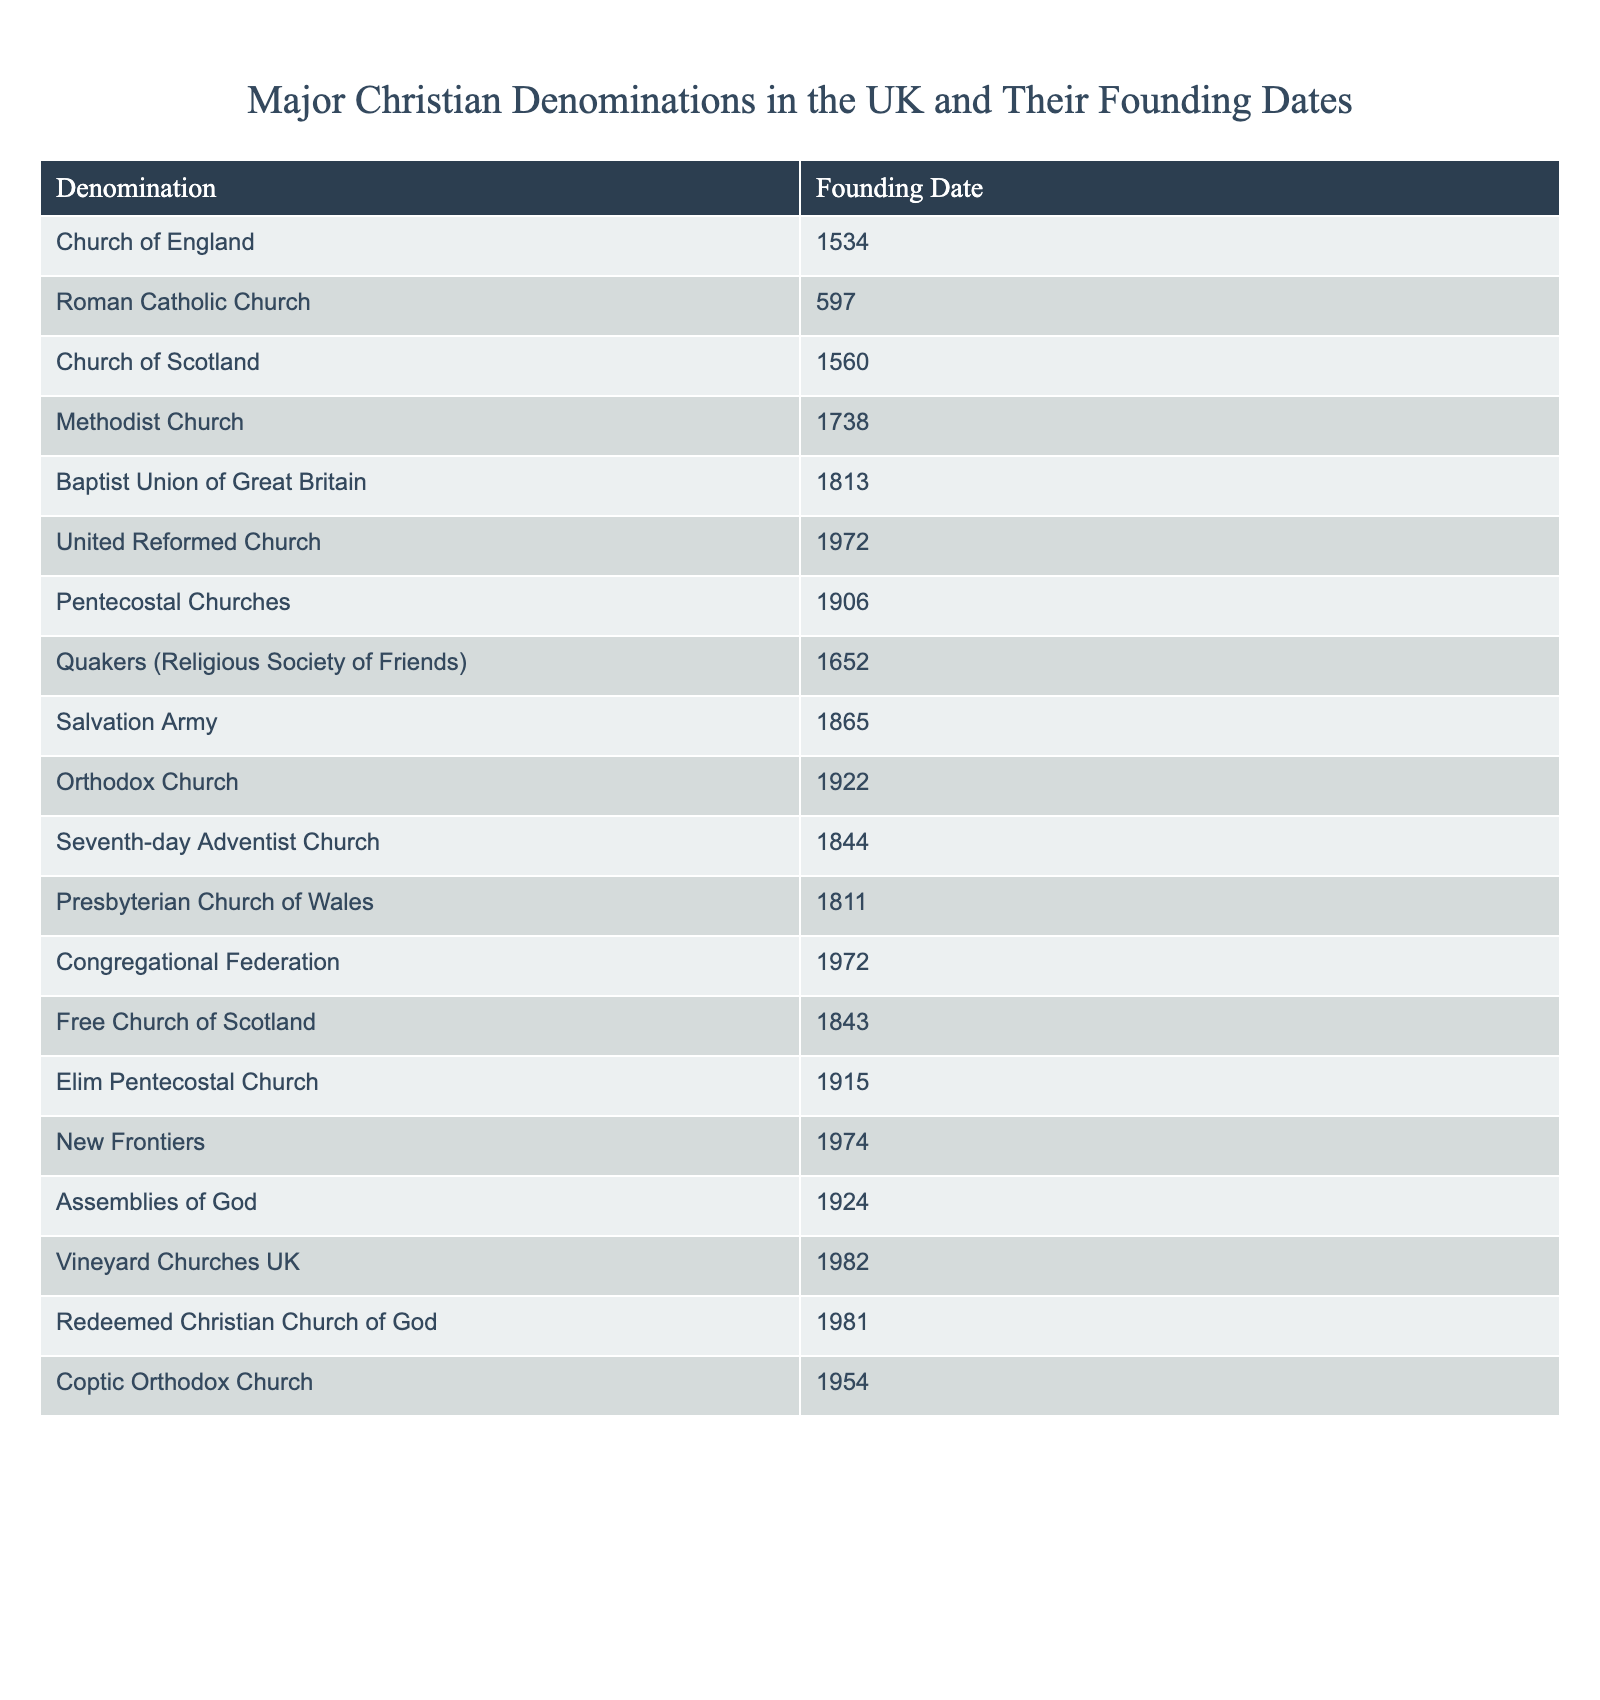What year was the Church of England founded? The founding date for the Church of England is listed in the table. I can directly refer to the row corresponding to the Church of England, which states that its founding date is 1534.
Answer: 1534 Which Christian denomination was founded first in the UK? To determine this, I can compare the founding dates of all denominations in the table. The Roman Catholic Church has the earliest founding date listed as 597.
Answer: Roman Catholic Church How many denominations were founded after 1800? First, I will filter the denominations founded after the year 1800, based on the founding dates provided. They are the Baptist Union of Great Britain (1813), Seventh-day Adventist Church (1844), Free Church of Scotland (1843), Salvation Army (1865), and Pentecostal Churches (1906). Counting these, we find there are 5 denominations.
Answer: 5 Is the United Reformed Church older than the Salvation Army? Looking at the founding years in the table, the United Reformed Church was founded in 1972, while the Salvation Army was founded in 1865. Since 1865 is earlier than 1972, the answer is no.
Answer: No Which denominations were founded in the 20th century? I need to identify which denominations emerged in the 1900s from the table. The denominations are the Pentecostal Churches (1906), Orthodox Church (1922), Assemblies of God (1924), Elim Pentecostal Church (1915), Vineyard Churches UK (1982), New Frontiers (1974), Coptic Orthodox Church (1954). Counting these gives us a total of 7 denominations.
Answer: 7 What is the difference in founding years between the Church of Scotland and the Methodist Church? The Church of Scotland was founded in 1560, while the Methodist Church was founded in 1738. To find the difference, I subtract 1560 from 1738, which equals 178 years.
Answer: 178 years Are there more denominations founded in the 16th century or the 19th century? I first identify the denominations from the table founded in the 16th century: Church of Scotland (1560) and Quakers (1652), totaling 2. For the 19th century, I find the following denominations: Baptist Union of Great Britain (1813), Seventh-day Adventist Church (1844), Free Church of Scotland (1843), Salvation Army (1865), which makes 4 denominations. So, there are more from the 19th century.
Answer: Yes Which is the latest founded Christian denomination on this list? To answer this, I will examine the founding years of all denominations and identify the latest one. The denomination with the latest founding year listed is Vineyard Churches UK, established in 1982.
Answer: Vineyard Churches UK 